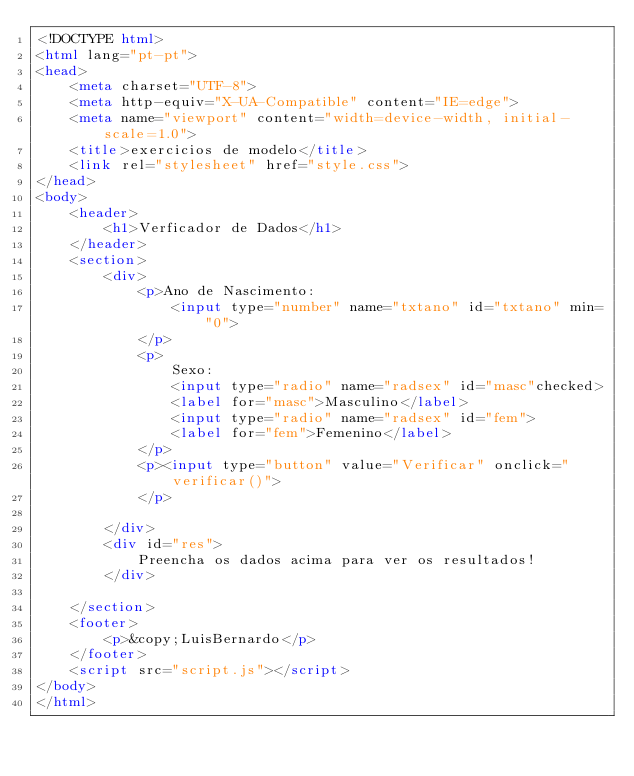Convert code to text. <code><loc_0><loc_0><loc_500><loc_500><_HTML_><!DOCTYPE html>
<html lang="pt-pt">
<head>
    <meta charset="UTF-8">
    <meta http-equiv="X-UA-Compatible" content="IE=edge">
    <meta name="viewport" content="width=device-width, initial-scale=1.0">
    <title>exercicios de modelo</title>
    <link rel="stylesheet" href="style.css">
</head>
<body>
    <header>
        <h1>Verficador de Dados</h1>
    </header>
    <section>
        <div>
            <p>Ano de Nascimento:
                <input type="number" name="txtano" id="txtano" min="0">
            </p>
            <p>
                Sexo:
                <input type="radio" name="radsex" id="masc"checked>
                <label for="masc">Masculino</label>
                <input type="radio" name="radsex" id="fem">
                <label for="fem">Femenino</label>
            </p>
            <p><input type="button" value="Verificar" onclick="verificar()">
            </p>
            
        </div>
        <div id="res">
            Preencha os dados acima para ver os resultados!
        </div>

    </section>
    <footer>
        <p>&copy;LuisBernardo</p>
    </footer>
    <script src="script.js"></script>
</body>
</html></code> 